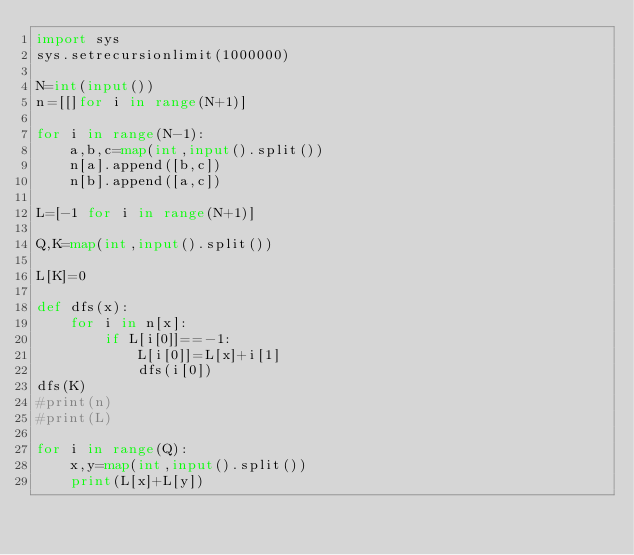<code> <loc_0><loc_0><loc_500><loc_500><_Python_>import sys
sys.setrecursionlimit(1000000)

N=int(input())
n=[[]for i in range(N+1)]

for i in range(N-1):
    a,b,c=map(int,input().split())
    n[a].append([b,c])
    n[b].append([a,c])
    
L=[-1 for i in range(N+1)]

Q,K=map(int,input().split())

L[K]=0

def dfs(x):
    for i in n[x]:
        if L[i[0]]==-1:
            L[i[0]]=L[x]+i[1]
            dfs(i[0])
dfs(K)
#print(n)
#print(L)

for i in range(Q):
    x,y=map(int,input().split())
    print(L[x]+L[y])</code> 